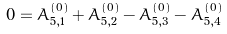<formula> <loc_0><loc_0><loc_500><loc_500>0 = A _ { 5 , 1 } ^ { ( 0 ) } + A _ { 5 , 2 } ^ { ( 0 ) } - A _ { 5 , 3 } ^ { ( 0 ) } - A _ { 5 , 4 } ^ { ( 0 ) }</formula> 